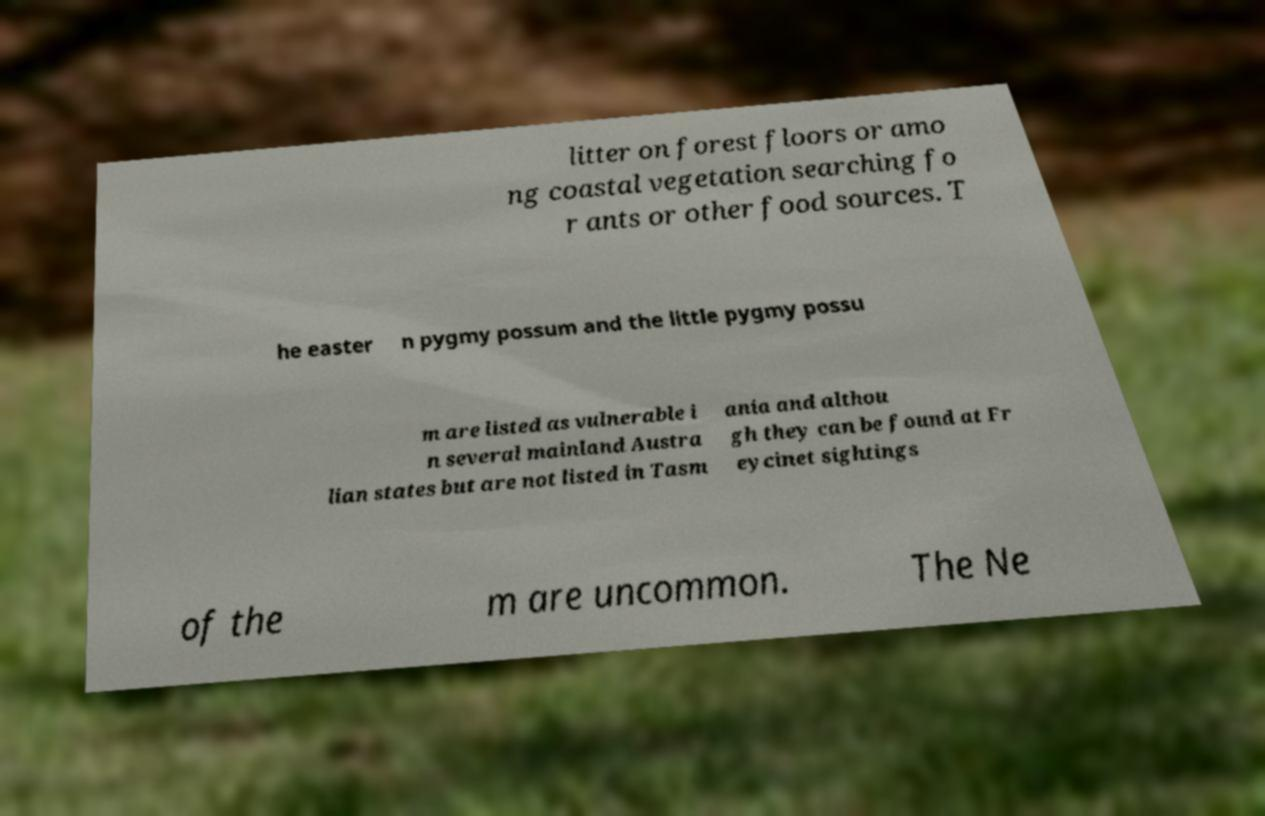There's text embedded in this image that I need extracted. Can you transcribe it verbatim? litter on forest floors or amo ng coastal vegetation searching fo r ants or other food sources. T he easter n pygmy possum and the little pygmy possu m are listed as vulnerable i n several mainland Austra lian states but are not listed in Tasm ania and althou gh they can be found at Fr eycinet sightings of the m are uncommon. The Ne 